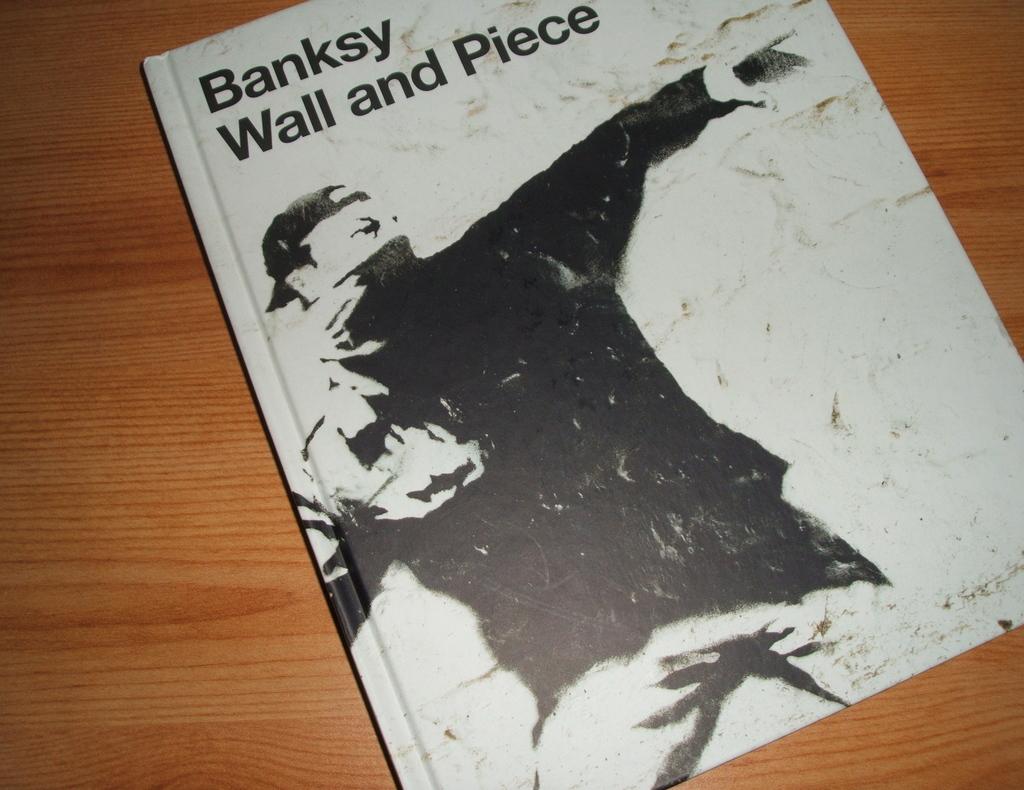What is the name of this book?
Provide a succinct answer. Banksy wall and piece. 